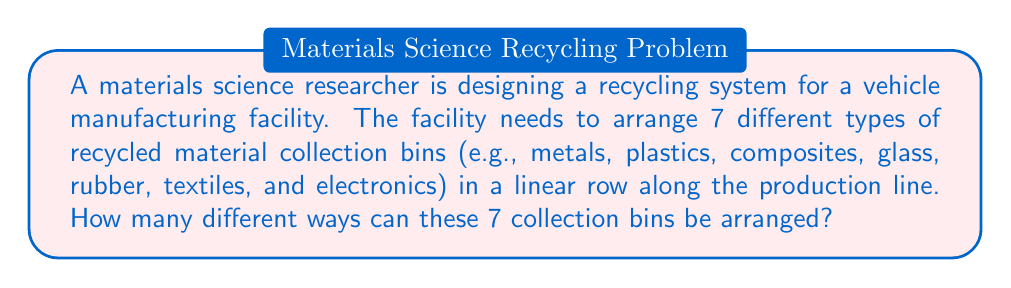Solve this math problem. To solve this problem, we need to recognize that this is a permutation problem. We are arranging all 7 bins in a specific order, and each bin is distinct.

1) The number of ways to arrange n distinct objects is given by the factorial of n, denoted as n!

2) In this case, we have 7 distinct bins, so n = 7

3) Therefore, the number of arrangements is 7!

4) Let's calculate 7!:
   
   $$7! = 7 \times 6 \times 5 \times 4 \times 3 \times 2 \times 1 = 5040$$

5) We can verify this result by considering the choices at each step:
   - For the first position, we have 7 choices
   - For the second position, we have 6 remaining choices
   - For the third position, we have 5 remaining choices
   - And so on...

   $$7 \times 6 \times 5 \times 4 \times 3 \times 2 \times 1 = 5040$$

Thus, there are 5040 different ways to arrange the 7 recycled material collection bins in the manufacturing facility.
Answer: 5040 